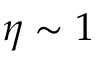<formula> <loc_0><loc_0><loc_500><loc_500>\eta \sim 1</formula> 